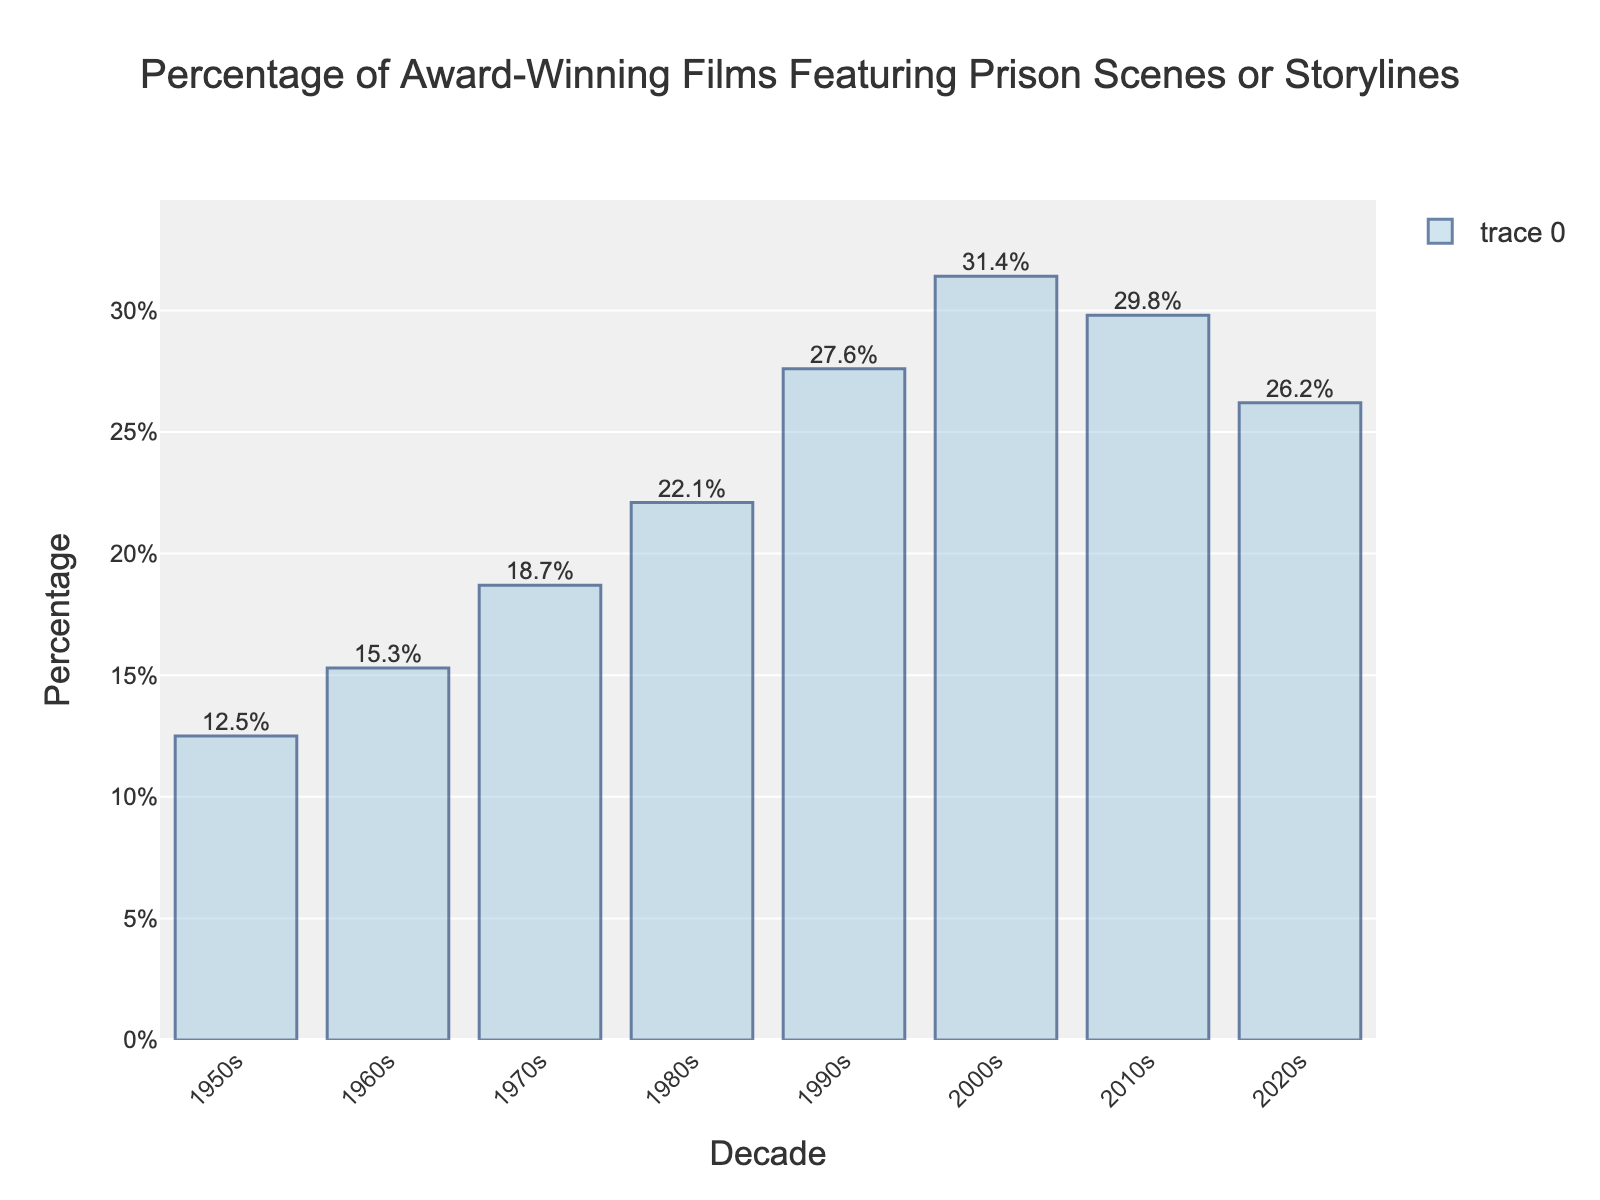What decade had the highest percentage of award-winning films featuring prison scenes or storylines? Observing the tallest bar in the chart, which represents the 2000s at 31.4%, shows it has the highest percentage.
Answer: 2000s What is the difference in percentage between the 1980s and the 2020s? The percentage for the 1980s is 22.1% and for the 2020s is 26.2%. The difference is calculated as 26.2% - 22.1% = 4.1%.
Answer: 4.1% Between which two consecutive decades was the increase in percentage the greatest? By comparing the differences between each consecutive decade: 1960s-1950s (2.8%), 1970s-1960s (3.4%), 1980s-1970s (3.4%), 1990s-1980s (5.5%), 2000s-1990s (3.8%), 2010s-2000s (-1.6%), 2020s-2010s (-3.6%), the greatest increase occurs between 1980s and 1990s at 5.5%.
Answer: 1980s to 1990s Which decade saw a decrease in the percentage of films featuring prison scenes compared to the previous decade? A decrease is observed when the height of the bar in the current decade is lower than the preceding decade. The 2010s (29.8%) decreased from the 2000s (31.4%). A decrease also occurred from the 2010s (29.8%) to the 2020s (26.2%).
Answer: 2010s, 2020s If you average the percentage of the 1950s, 1960s, and the 1970s, what is the result? The percentages for the 1950s, 1960s, and 1970s are 12.5%, 15.3%, and 18.7% respectively. The sum is 12.5 + 15.3 + 18.7 = 46.5. The average is 46.5 / 3 = 15.5%.
Answer: 15.5% By how much did the percentage of films with prison scenes increase from the 1950s to the 2000s? The percentage in the 1950s is 12.5% and in the 2000s is 31.4%. The increase is calculated as 31.4% - 12.5% = 18.9%.
Answer: 18.9% Which decade had the lowest percentage of films featuring prison scenes or storylines? Observing the shortest bar, which is the 1950s at 12.5%, reveals it had the lowest percentage.
Answer: 1950s What is the total percentage increase from the 1950s to the 2010s? The percentage in the 1950s is 12.5% and in the 2010s is 29.8%. The total increase is 29.8% - 12.5% = 17.3%.
Answer: 17.3% Comparing the 1990s and the 2020s, which experienced a higher percentage? By how much? The percentage for the 1990s is 27.6% and for the 2020s is 26.2%. The 1990s have a higher percentage by 27.6% - 26.2% = 1.4%.
Answer: 1990s, 1.4% 